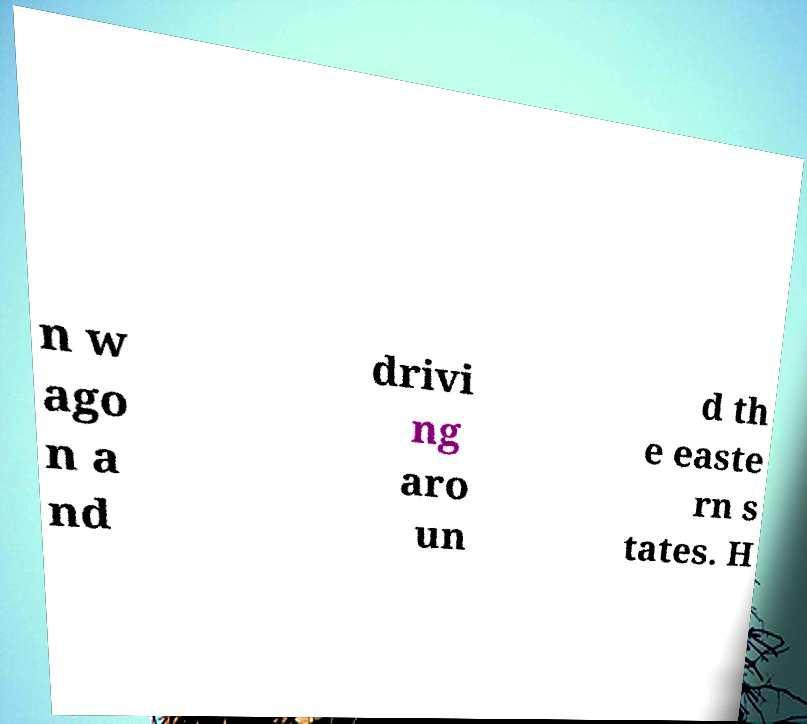For documentation purposes, I need the text within this image transcribed. Could you provide that? n w ago n a nd drivi ng aro un d th e easte rn s tates. H 